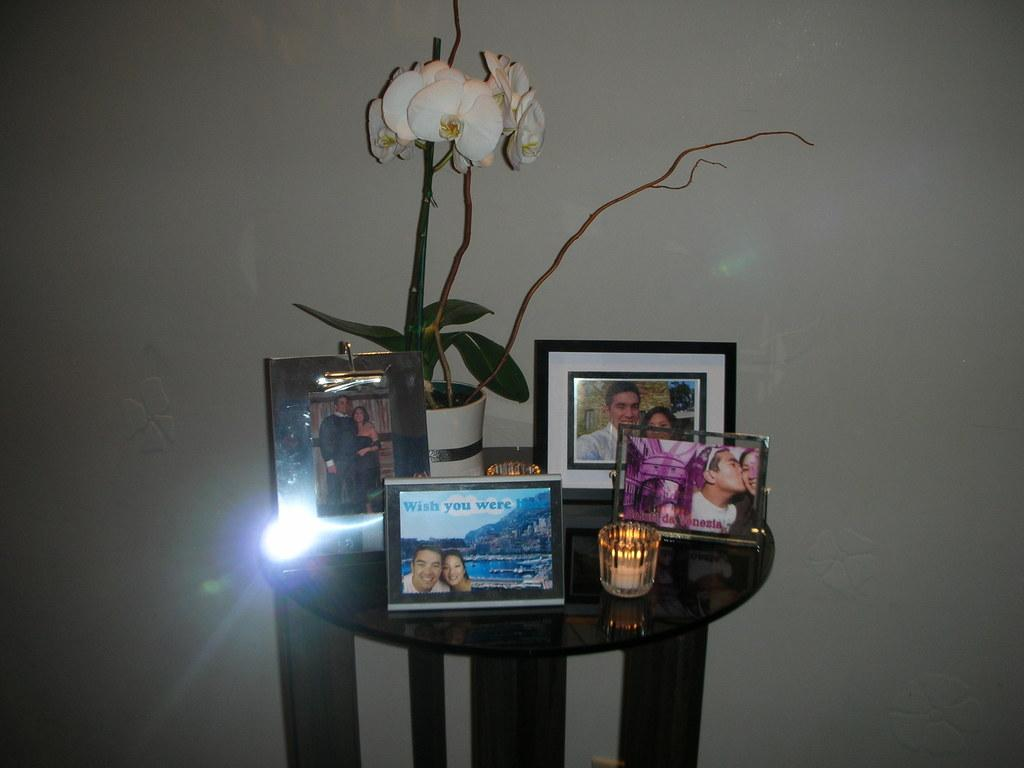<image>
Relay a brief, clear account of the picture shown. A table with a white orchid on it and a lot of framed pictures with one that says "wish you were here". 